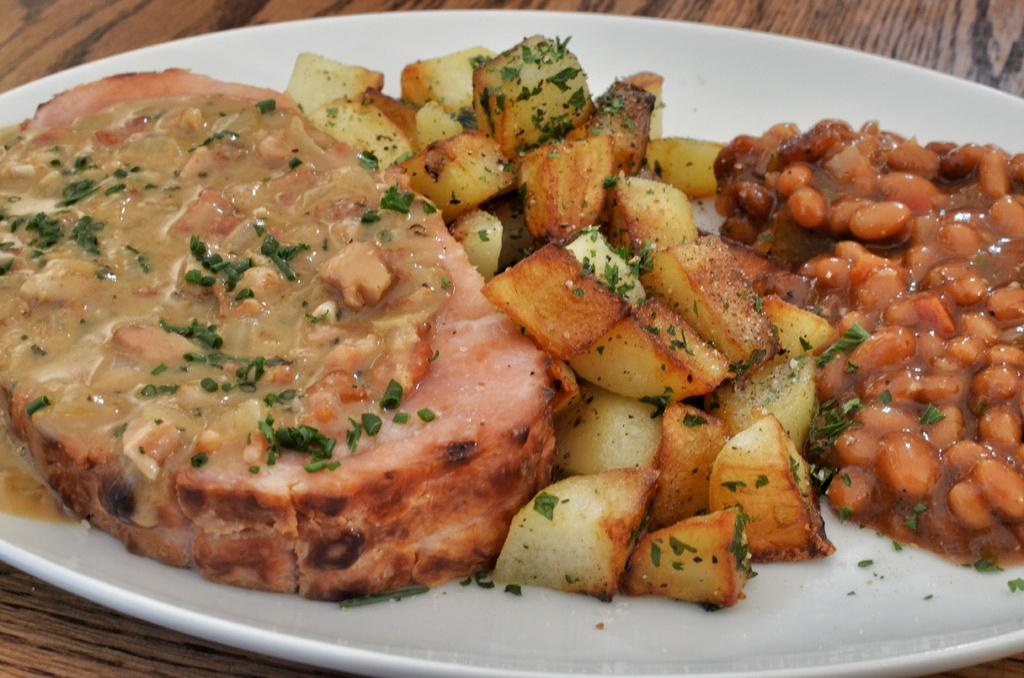What is the main object in the center of the image? There is a white color palette in the image, and it is in the center. What is on the palette? The palette contains food items. What color is the palette? The palette is white. What can be seen in the background of the image? There is a brown color object in the background, which appears to be a table. How many cameras are visible in the image? There are no cameras visible in the image. What type of produce is on the palette? The provided facts do not mention any produce on the palette; it only states that the palette contains food items. 